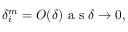Convert formula to latex. <formula><loc_0><loc_0><loc_500><loc_500>\delta _ { i } ^ { m } = O ( \delta ) a s \delta \rightarrow 0 ,</formula> 